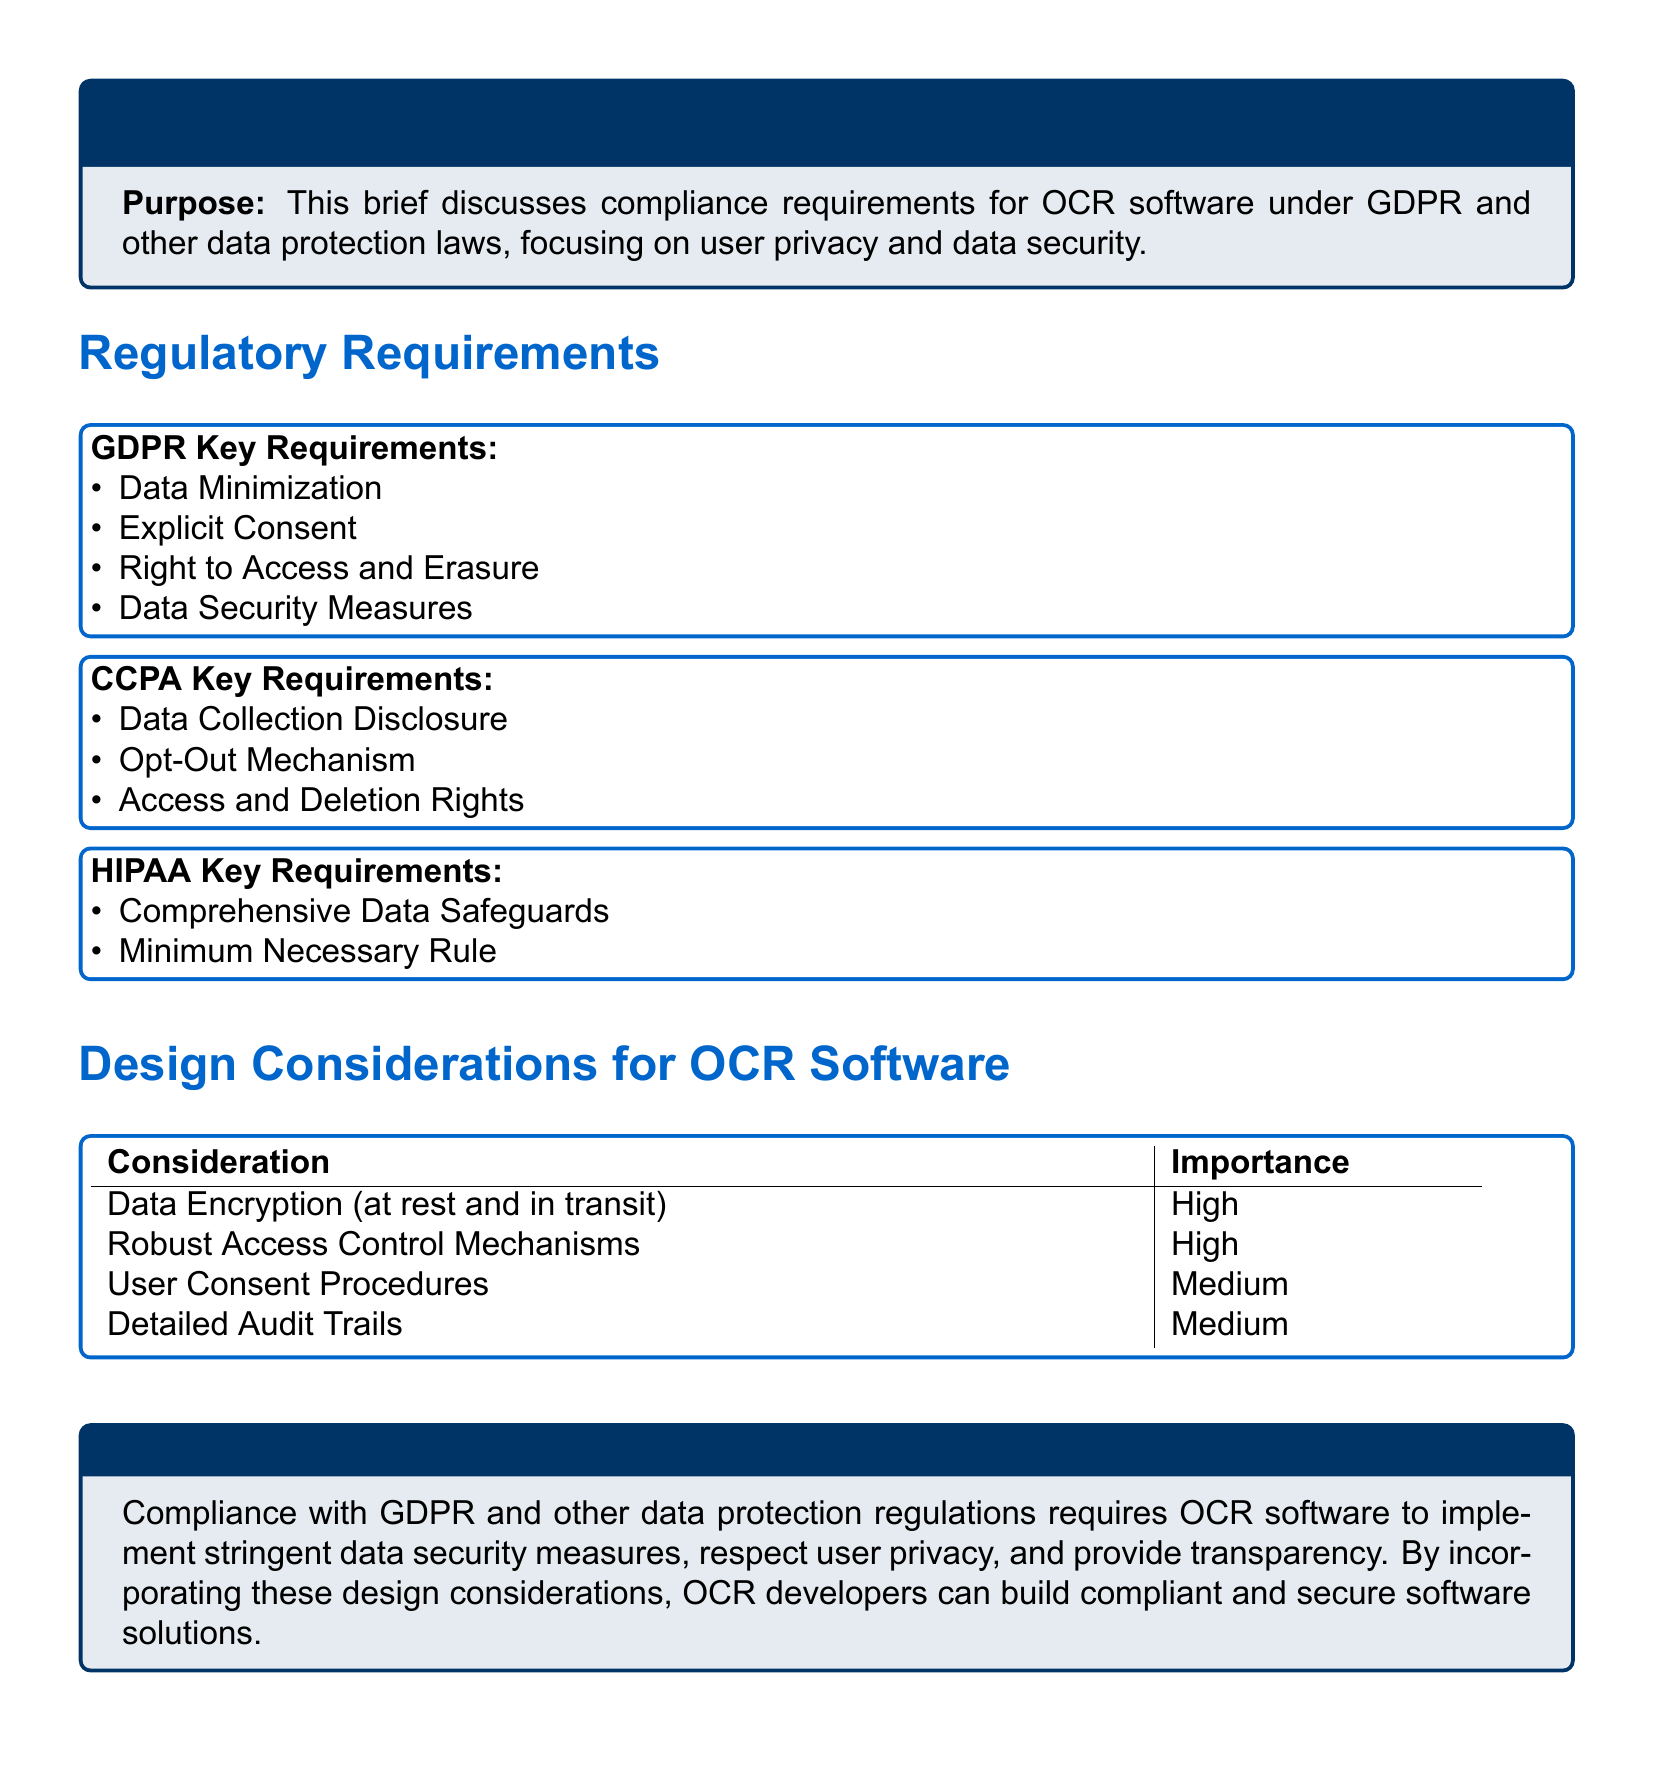What are the GDPR key requirements? The GDPR key requirements listed in the document include data minimization, explicit consent, the right to access and erasure, and data security measures.
Answer: Data Minimization, Explicit Consent, Right to Access and Erasure, Data Security Measures What is a key requirement of CCPA? The document states that a key requirement of CCPA is the opt-out mechanism for consumers.
Answer: Opt-Out Mechanism How many design considerations for OCR software are mentioned? The document lists four design considerations for OCR software, including data encryption, access control, user consent procedures, and audit trails.
Answer: Four What is the importance level of user consent procedures? According to the document, user consent procedures have a medium importance level in the design considerations for OCR software.
Answer: Medium What is the purpose of the legal brief? The purpose outlined in the document is to discuss compliance requirements for OCR software under GDPR and other data protection laws, focusing on user privacy and data security.
Answer: Compliance requirements for OCR software under GDPR and other data protection laws What is required for compliance with GDPR according to the conclusion? The conclusion states that compliance with GDPR requires OCR software to implement stringent data security measures and respect user privacy.
Answer: Stringent data security measures and respect user privacy 